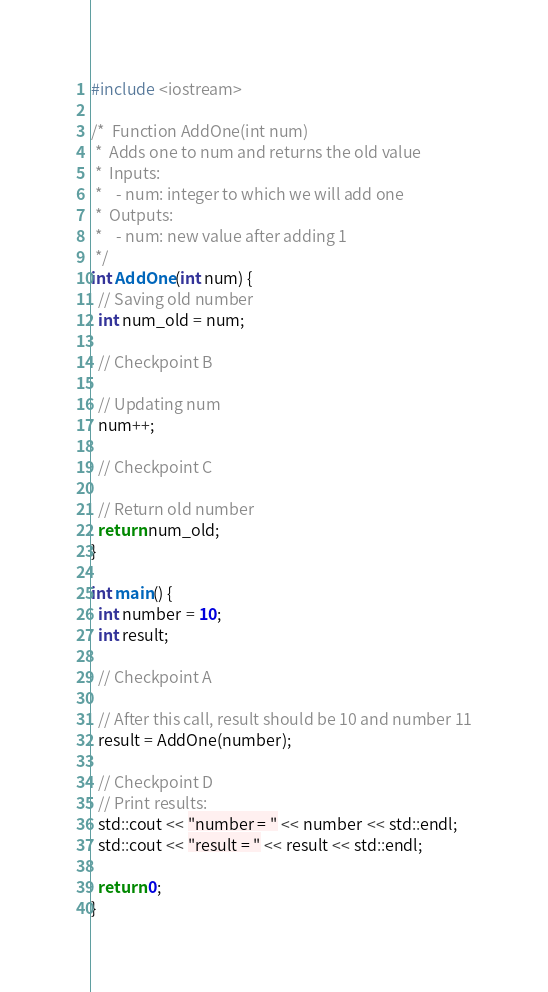Convert code to text. <code><loc_0><loc_0><loc_500><loc_500><_C++_>#include <iostream>

/*  Function AddOne(int num)
 *  Adds one to num and returns the old value
 *  Inputs:
 *    - num: integer to which we will add one
 *  Outputs:
 *    - num: new value after adding 1
 */
int AddOne(int num) {
  // Saving old number
  int num_old = num;

  // Checkpoint B

  // Updating num
  num++;

  // Checkpoint C

  // Return old number
  return num_old;
}

int main() {
  int number = 10;
  int result;

  // Checkpoint A

  // After this call, result should be 10 and number 11
  result = AddOne(number);

  // Checkpoint D
  // Print results:
  std::cout << "number = " << number << std::endl;
  std::cout << "result = " << result << std::endl;

  return 0;
}
</code> 